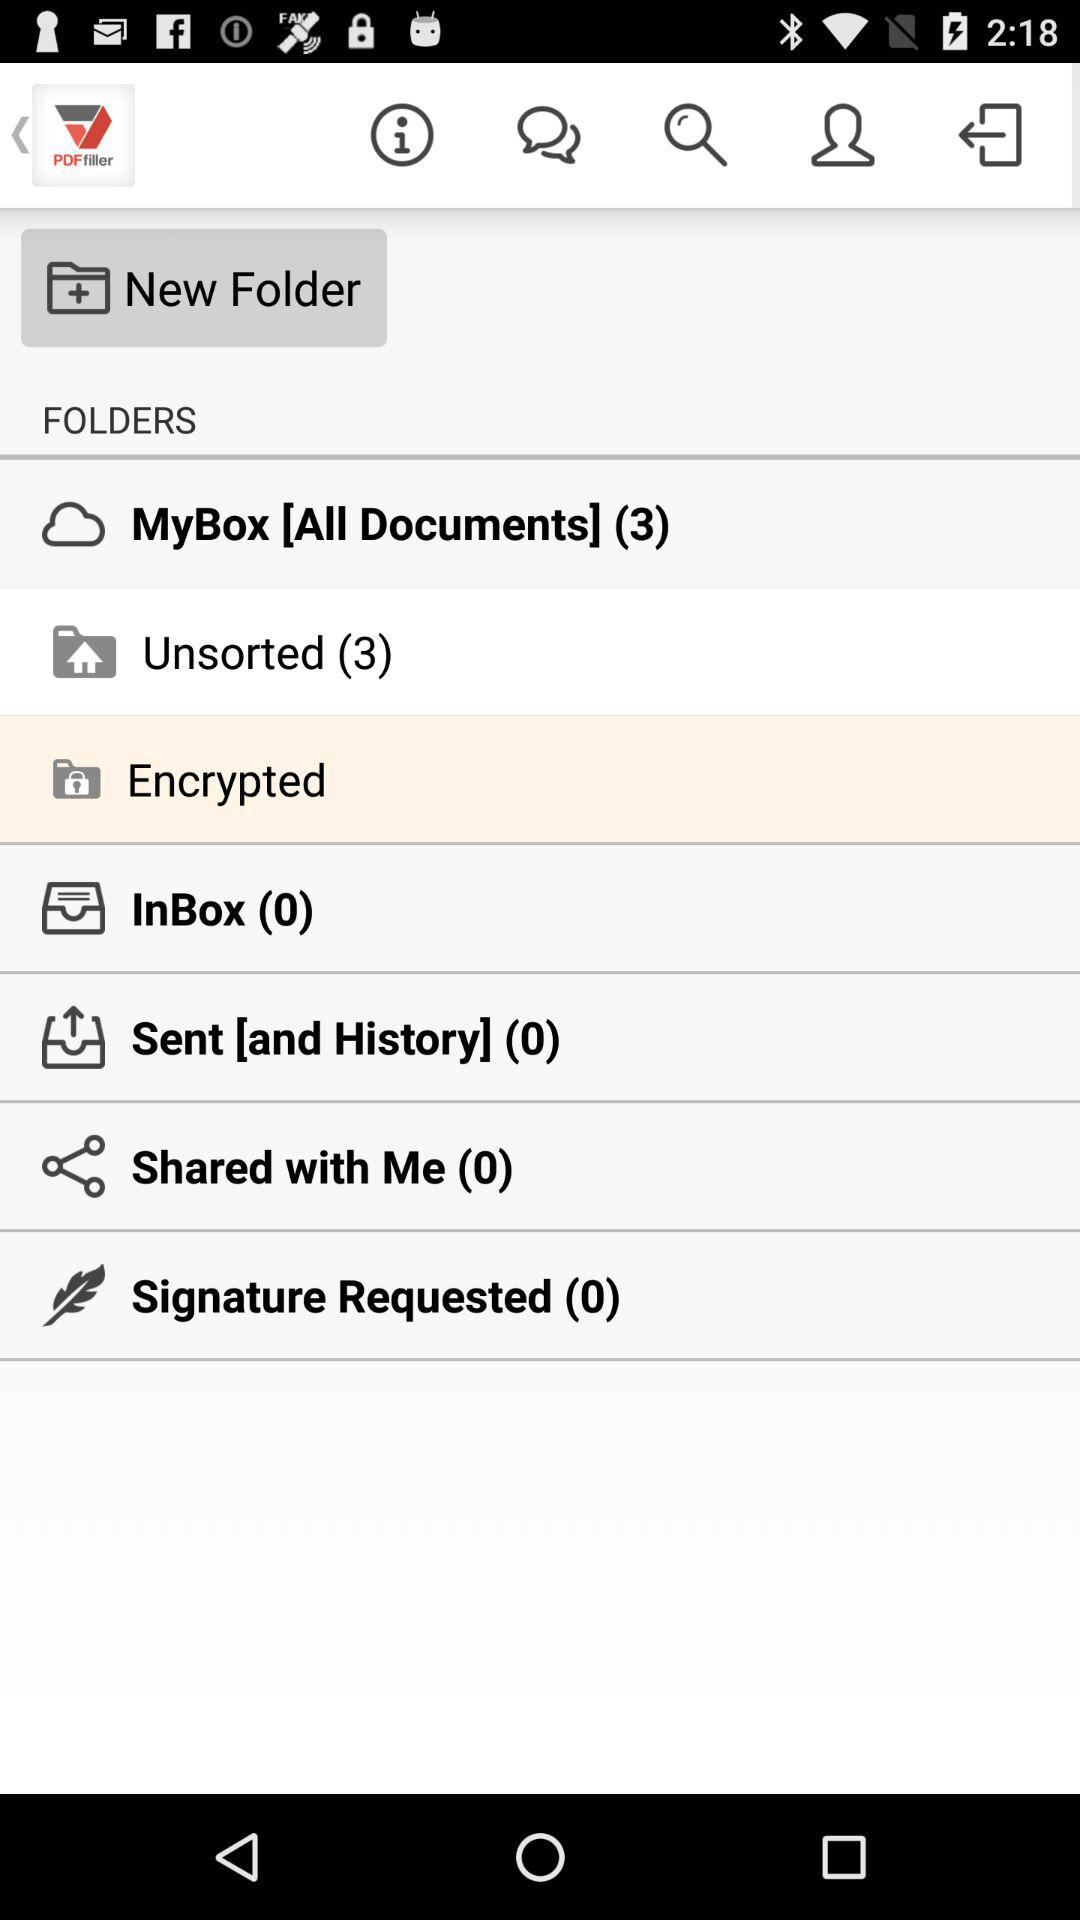Is there an message in inbox?
When the provided information is insufficient, respond with <no answer>. <no answer> 